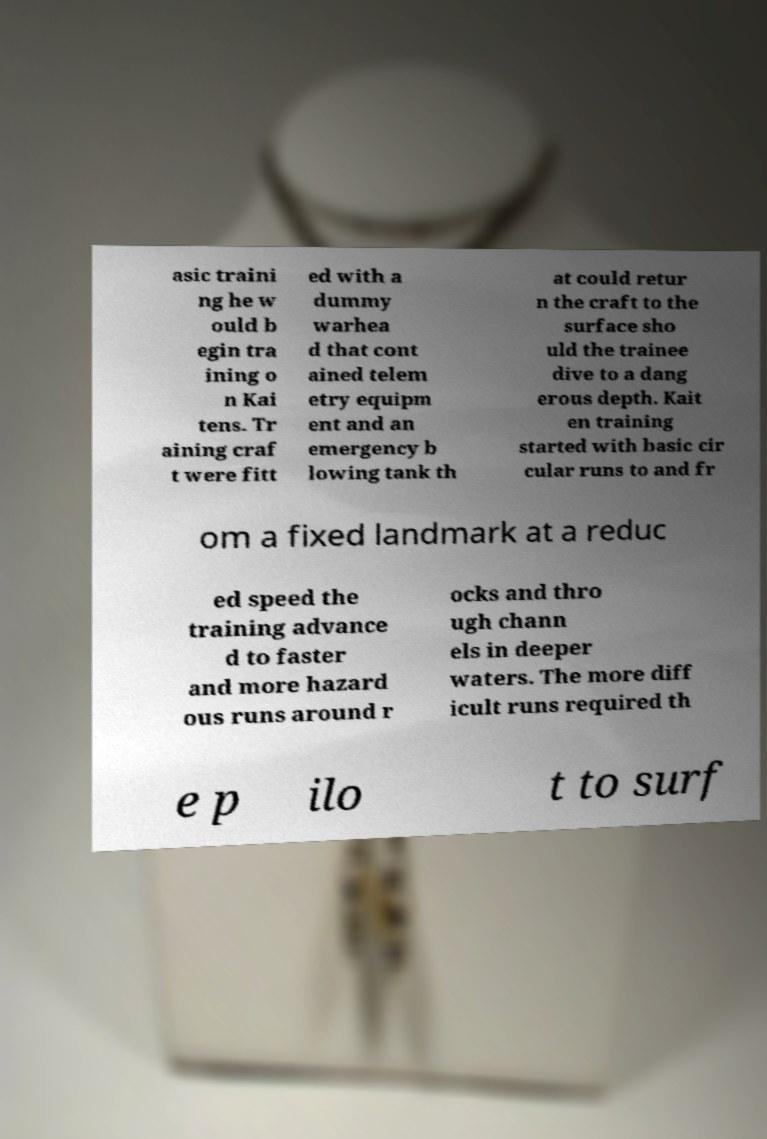Can you accurately transcribe the text from the provided image for me? asic traini ng he w ould b egin tra ining o n Kai tens. Tr aining craf t were fitt ed with a dummy warhea d that cont ained telem etry equipm ent and an emergency b lowing tank th at could retur n the craft to the surface sho uld the trainee dive to a dang erous depth. Kait en training started with basic cir cular runs to and fr om a fixed landmark at a reduc ed speed the training advance d to faster and more hazard ous runs around r ocks and thro ugh chann els in deeper waters. The more diff icult runs required th e p ilo t to surf 